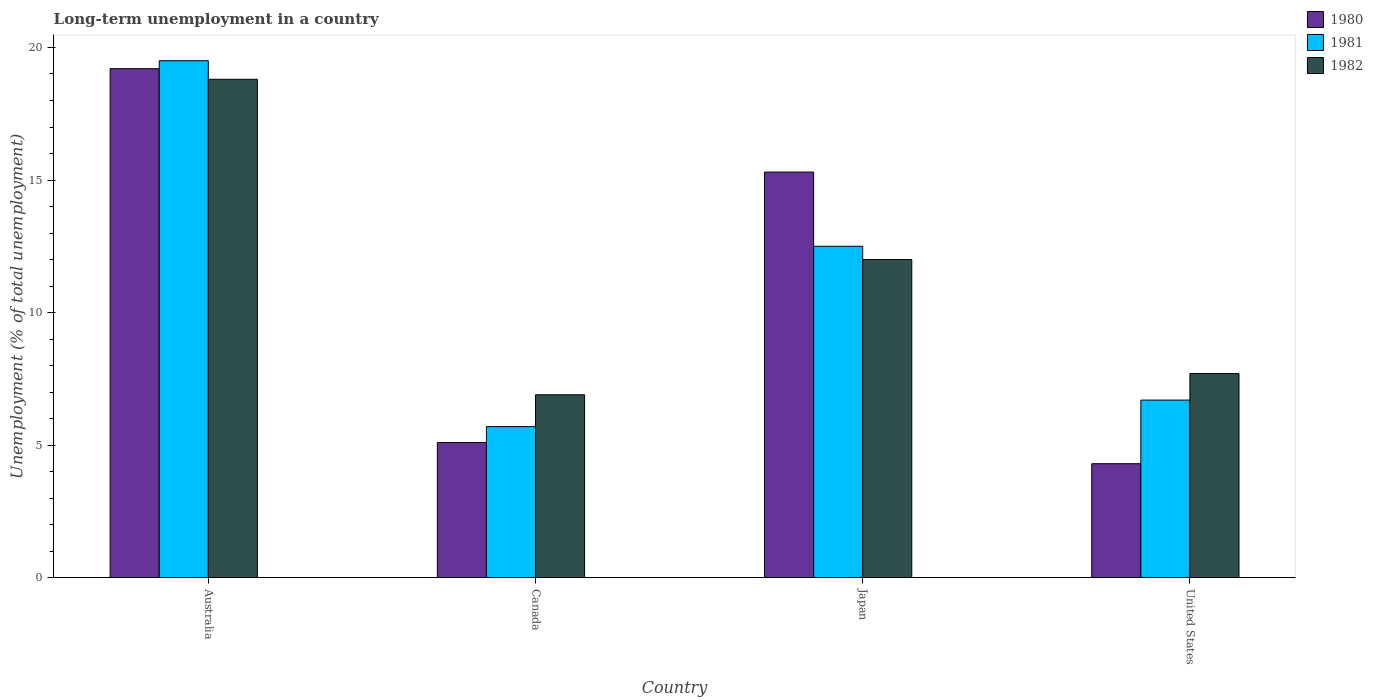How many different coloured bars are there?
Provide a short and direct response. 3. What is the percentage of long-term unemployed population in 1981 in United States?
Your answer should be very brief. 6.7. Across all countries, what is the maximum percentage of long-term unemployed population in 1982?
Ensure brevity in your answer.  18.8. Across all countries, what is the minimum percentage of long-term unemployed population in 1982?
Give a very brief answer. 6.9. In which country was the percentage of long-term unemployed population in 1982 minimum?
Offer a very short reply. Canada. What is the total percentage of long-term unemployed population in 1982 in the graph?
Make the answer very short. 45.4. What is the difference between the percentage of long-term unemployed population in 1980 in Australia and that in Japan?
Provide a succinct answer. 3.9. What is the difference between the percentage of long-term unemployed population in 1982 in Japan and the percentage of long-term unemployed population in 1981 in Australia?
Provide a short and direct response. -7.5. What is the average percentage of long-term unemployed population in 1981 per country?
Offer a terse response. 11.1. What is the difference between the percentage of long-term unemployed population of/in 1982 and percentage of long-term unemployed population of/in 1980 in Japan?
Provide a short and direct response. -3.3. What is the ratio of the percentage of long-term unemployed population in 1982 in Japan to that in United States?
Give a very brief answer. 1.56. Is the percentage of long-term unemployed population in 1982 in Canada less than that in Japan?
Give a very brief answer. Yes. What is the difference between the highest and the second highest percentage of long-term unemployed population in 1982?
Offer a terse response. 6.8. What is the difference between the highest and the lowest percentage of long-term unemployed population in 1980?
Provide a short and direct response. 14.9. Is the sum of the percentage of long-term unemployed population in 1981 in Canada and United States greater than the maximum percentage of long-term unemployed population in 1982 across all countries?
Your response must be concise. No. What does the 1st bar from the left in Australia represents?
Your answer should be compact. 1980. Is it the case that in every country, the sum of the percentage of long-term unemployed population in 1980 and percentage of long-term unemployed population in 1981 is greater than the percentage of long-term unemployed population in 1982?
Give a very brief answer. Yes. How many bars are there?
Your answer should be very brief. 12. Are all the bars in the graph horizontal?
Your answer should be compact. No. What is the difference between two consecutive major ticks on the Y-axis?
Your answer should be compact. 5. Are the values on the major ticks of Y-axis written in scientific E-notation?
Provide a short and direct response. No. Does the graph contain any zero values?
Ensure brevity in your answer.  No. Does the graph contain grids?
Make the answer very short. No. Where does the legend appear in the graph?
Provide a succinct answer. Top right. How many legend labels are there?
Offer a very short reply. 3. What is the title of the graph?
Provide a succinct answer. Long-term unemployment in a country. Does "1966" appear as one of the legend labels in the graph?
Give a very brief answer. No. What is the label or title of the X-axis?
Provide a succinct answer. Country. What is the label or title of the Y-axis?
Provide a succinct answer. Unemployment (% of total unemployment). What is the Unemployment (% of total unemployment) in 1980 in Australia?
Your answer should be compact. 19.2. What is the Unemployment (% of total unemployment) of 1981 in Australia?
Keep it short and to the point. 19.5. What is the Unemployment (% of total unemployment) in 1982 in Australia?
Make the answer very short. 18.8. What is the Unemployment (% of total unemployment) in 1980 in Canada?
Offer a terse response. 5.1. What is the Unemployment (% of total unemployment) of 1981 in Canada?
Ensure brevity in your answer.  5.7. What is the Unemployment (% of total unemployment) in 1982 in Canada?
Your response must be concise. 6.9. What is the Unemployment (% of total unemployment) in 1980 in Japan?
Make the answer very short. 15.3. What is the Unemployment (% of total unemployment) of 1980 in United States?
Your answer should be compact. 4.3. What is the Unemployment (% of total unemployment) in 1981 in United States?
Your response must be concise. 6.7. What is the Unemployment (% of total unemployment) in 1982 in United States?
Your answer should be very brief. 7.7. Across all countries, what is the maximum Unemployment (% of total unemployment) in 1980?
Make the answer very short. 19.2. Across all countries, what is the maximum Unemployment (% of total unemployment) of 1982?
Keep it short and to the point. 18.8. Across all countries, what is the minimum Unemployment (% of total unemployment) of 1980?
Provide a short and direct response. 4.3. Across all countries, what is the minimum Unemployment (% of total unemployment) in 1981?
Provide a short and direct response. 5.7. Across all countries, what is the minimum Unemployment (% of total unemployment) of 1982?
Make the answer very short. 6.9. What is the total Unemployment (% of total unemployment) of 1980 in the graph?
Provide a short and direct response. 43.9. What is the total Unemployment (% of total unemployment) in 1981 in the graph?
Your answer should be very brief. 44.4. What is the total Unemployment (% of total unemployment) in 1982 in the graph?
Offer a terse response. 45.4. What is the difference between the Unemployment (% of total unemployment) in 1980 in Australia and that in Canada?
Give a very brief answer. 14.1. What is the difference between the Unemployment (% of total unemployment) of 1982 in Australia and that in Canada?
Your response must be concise. 11.9. What is the difference between the Unemployment (% of total unemployment) of 1982 in Australia and that in Japan?
Give a very brief answer. 6.8. What is the difference between the Unemployment (% of total unemployment) of 1980 in Australia and that in United States?
Keep it short and to the point. 14.9. What is the difference between the Unemployment (% of total unemployment) of 1982 in Australia and that in United States?
Give a very brief answer. 11.1. What is the difference between the Unemployment (% of total unemployment) in 1981 in Canada and that in Japan?
Offer a very short reply. -6.8. What is the difference between the Unemployment (% of total unemployment) of 1982 in Canada and that in Japan?
Give a very brief answer. -5.1. What is the difference between the Unemployment (% of total unemployment) in 1980 in Japan and that in United States?
Provide a succinct answer. 11. What is the difference between the Unemployment (% of total unemployment) of 1982 in Japan and that in United States?
Your answer should be compact. 4.3. What is the difference between the Unemployment (% of total unemployment) in 1980 in Australia and the Unemployment (% of total unemployment) in 1981 in Canada?
Your response must be concise. 13.5. What is the difference between the Unemployment (% of total unemployment) of 1980 in Australia and the Unemployment (% of total unemployment) of 1982 in Canada?
Offer a very short reply. 12.3. What is the difference between the Unemployment (% of total unemployment) in 1981 in Australia and the Unemployment (% of total unemployment) in 1982 in Canada?
Your answer should be compact. 12.6. What is the difference between the Unemployment (% of total unemployment) of 1980 in Australia and the Unemployment (% of total unemployment) of 1981 in Japan?
Provide a short and direct response. 6.7. What is the difference between the Unemployment (% of total unemployment) of 1980 in Australia and the Unemployment (% of total unemployment) of 1982 in Japan?
Provide a short and direct response. 7.2. What is the difference between the Unemployment (% of total unemployment) in 1980 in Australia and the Unemployment (% of total unemployment) in 1981 in United States?
Your response must be concise. 12.5. What is the difference between the Unemployment (% of total unemployment) in 1980 in Canada and the Unemployment (% of total unemployment) in 1982 in Japan?
Give a very brief answer. -6.9. What is the difference between the Unemployment (% of total unemployment) of 1981 in Japan and the Unemployment (% of total unemployment) of 1982 in United States?
Keep it short and to the point. 4.8. What is the average Unemployment (% of total unemployment) in 1980 per country?
Keep it short and to the point. 10.97. What is the average Unemployment (% of total unemployment) of 1982 per country?
Offer a terse response. 11.35. What is the difference between the Unemployment (% of total unemployment) of 1981 and Unemployment (% of total unemployment) of 1982 in Australia?
Offer a terse response. 0.7. What is the difference between the Unemployment (% of total unemployment) in 1981 and Unemployment (% of total unemployment) in 1982 in Canada?
Offer a very short reply. -1.2. What is the difference between the Unemployment (% of total unemployment) of 1980 and Unemployment (% of total unemployment) of 1982 in Japan?
Make the answer very short. 3.3. What is the difference between the Unemployment (% of total unemployment) of 1981 and Unemployment (% of total unemployment) of 1982 in Japan?
Provide a short and direct response. 0.5. What is the difference between the Unemployment (% of total unemployment) in 1980 and Unemployment (% of total unemployment) in 1981 in United States?
Ensure brevity in your answer.  -2.4. What is the difference between the Unemployment (% of total unemployment) in 1980 and Unemployment (% of total unemployment) in 1982 in United States?
Provide a short and direct response. -3.4. What is the difference between the Unemployment (% of total unemployment) of 1981 and Unemployment (% of total unemployment) of 1982 in United States?
Give a very brief answer. -1. What is the ratio of the Unemployment (% of total unemployment) of 1980 in Australia to that in Canada?
Make the answer very short. 3.76. What is the ratio of the Unemployment (% of total unemployment) of 1981 in Australia to that in Canada?
Offer a very short reply. 3.42. What is the ratio of the Unemployment (% of total unemployment) of 1982 in Australia to that in Canada?
Ensure brevity in your answer.  2.72. What is the ratio of the Unemployment (% of total unemployment) of 1980 in Australia to that in Japan?
Your answer should be compact. 1.25. What is the ratio of the Unemployment (% of total unemployment) in 1981 in Australia to that in Japan?
Offer a very short reply. 1.56. What is the ratio of the Unemployment (% of total unemployment) of 1982 in Australia to that in Japan?
Offer a very short reply. 1.57. What is the ratio of the Unemployment (% of total unemployment) in 1980 in Australia to that in United States?
Your answer should be compact. 4.47. What is the ratio of the Unemployment (% of total unemployment) of 1981 in Australia to that in United States?
Offer a very short reply. 2.91. What is the ratio of the Unemployment (% of total unemployment) of 1982 in Australia to that in United States?
Your answer should be very brief. 2.44. What is the ratio of the Unemployment (% of total unemployment) in 1981 in Canada to that in Japan?
Make the answer very short. 0.46. What is the ratio of the Unemployment (% of total unemployment) in 1982 in Canada to that in Japan?
Provide a short and direct response. 0.57. What is the ratio of the Unemployment (% of total unemployment) of 1980 in Canada to that in United States?
Provide a short and direct response. 1.19. What is the ratio of the Unemployment (% of total unemployment) of 1981 in Canada to that in United States?
Your answer should be compact. 0.85. What is the ratio of the Unemployment (% of total unemployment) of 1982 in Canada to that in United States?
Give a very brief answer. 0.9. What is the ratio of the Unemployment (% of total unemployment) of 1980 in Japan to that in United States?
Give a very brief answer. 3.56. What is the ratio of the Unemployment (% of total unemployment) of 1981 in Japan to that in United States?
Your response must be concise. 1.87. What is the ratio of the Unemployment (% of total unemployment) of 1982 in Japan to that in United States?
Offer a terse response. 1.56. What is the difference between the highest and the second highest Unemployment (% of total unemployment) in 1981?
Your answer should be very brief. 7. What is the difference between the highest and the lowest Unemployment (% of total unemployment) in 1980?
Your response must be concise. 14.9. What is the difference between the highest and the lowest Unemployment (% of total unemployment) in 1981?
Make the answer very short. 13.8. 